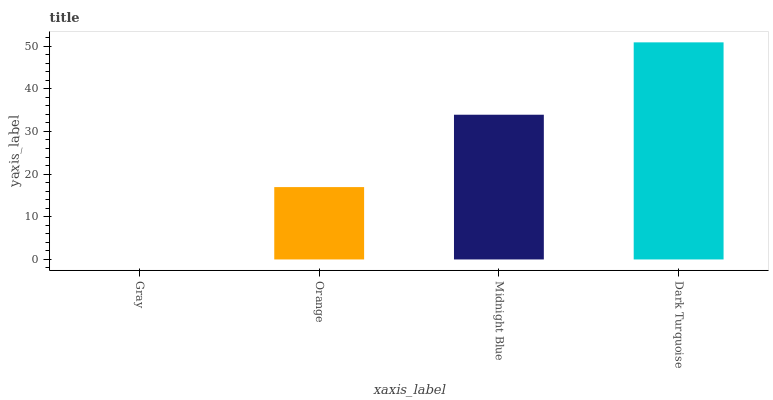Is Orange the minimum?
Answer yes or no. No. Is Orange the maximum?
Answer yes or no. No. Is Orange greater than Gray?
Answer yes or no. Yes. Is Gray less than Orange?
Answer yes or no. Yes. Is Gray greater than Orange?
Answer yes or no. No. Is Orange less than Gray?
Answer yes or no. No. Is Midnight Blue the high median?
Answer yes or no. Yes. Is Orange the low median?
Answer yes or no. Yes. Is Gray the high median?
Answer yes or no. No. Is Midnight Blue the low median?
Answer yes or no. No. 